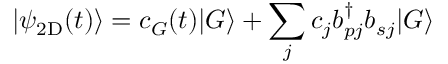<formula> <loc_0><loc_0><loc_500><loc_500>| \psi _ { 2 D } ( t ) \rangle = c _ { G } ( t ) | G \rangle + \sum _ { j } c _ { j } b _ { p j } ^ { \dagger } b _ { s j } | G \rangle</formula> 